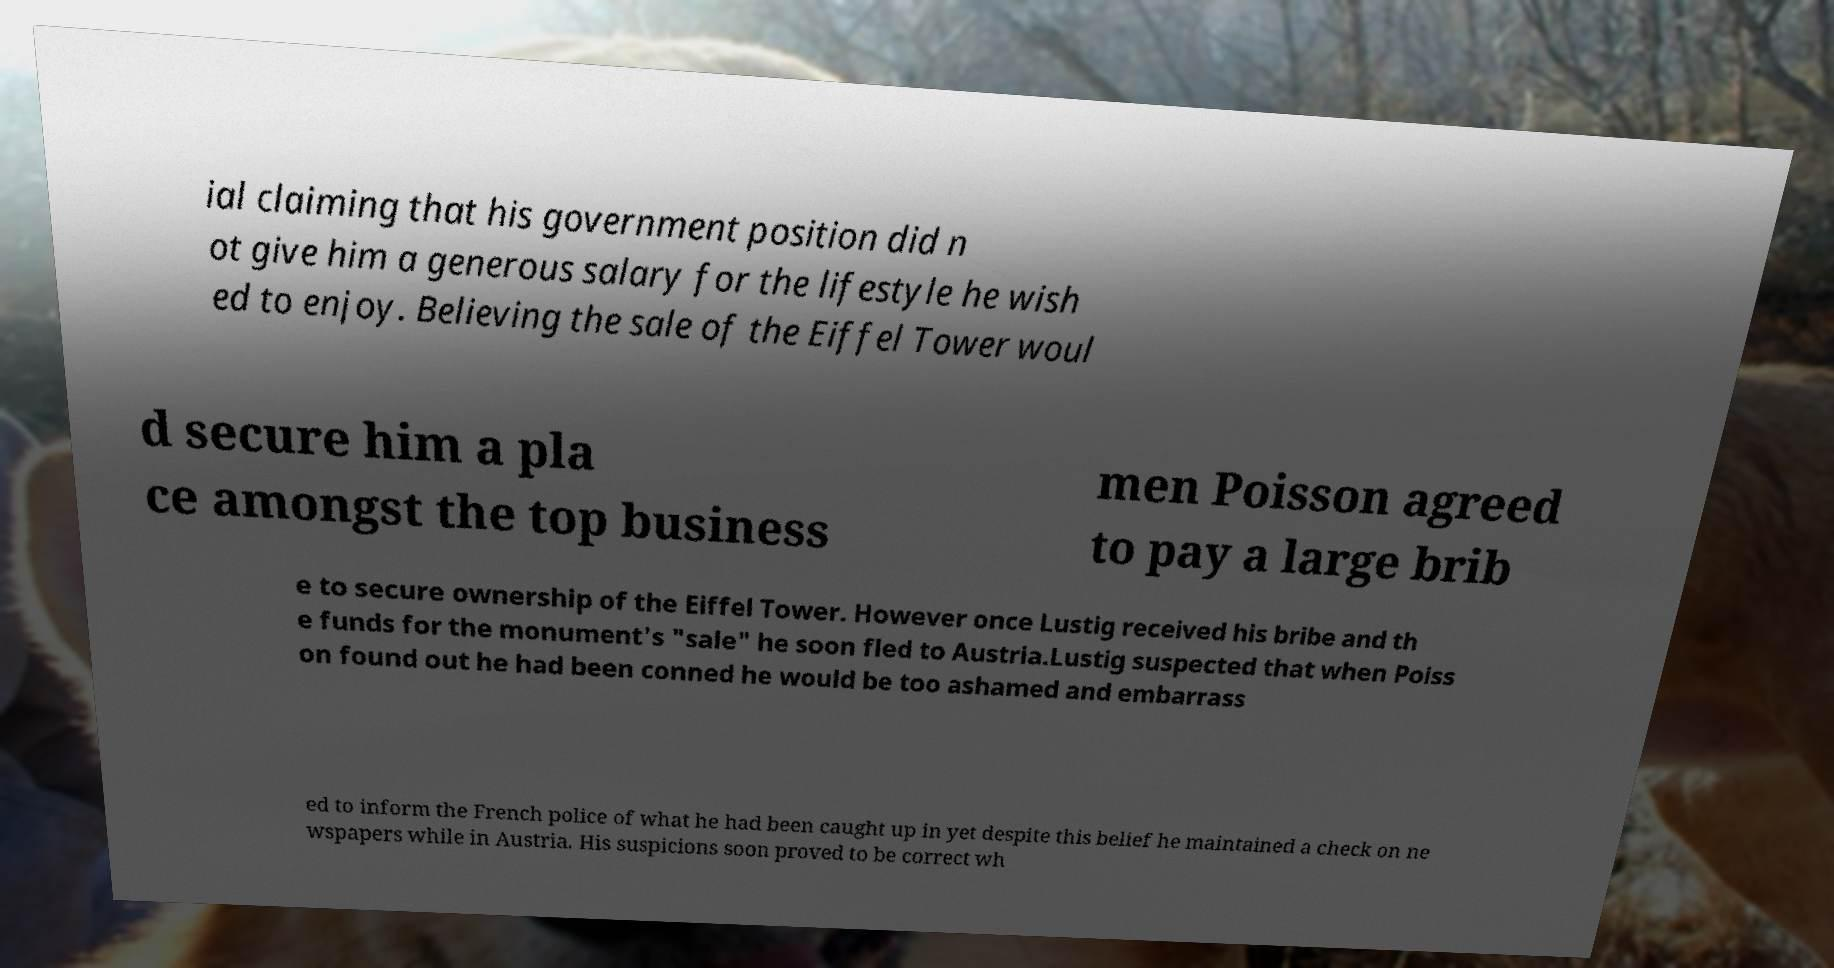For documentation purposes, I need the text within this image transcribed. Could you provide that? ial claiming that his government position did n ot give him a generous salary for the lifestyle he wish ed to enjoy. Believing the sale of the Eiffel Tower woul d secure him a pla ce amongst the top business men Poisson agreed to pay a large brib e to secure ownership of the Eiffel Tower. However once Lustig received his bribe and th e funds for the monument's "sale" he soon fled to Austria.Lustig suspected that when Poiss on found out he had been conned he would be too ashamed and embarrass ed to inform the French police of what he had been caught up in yet despite this belief he maintained a check on ne wspapers while in Austria. His suspicions soon proved to be correct wh 